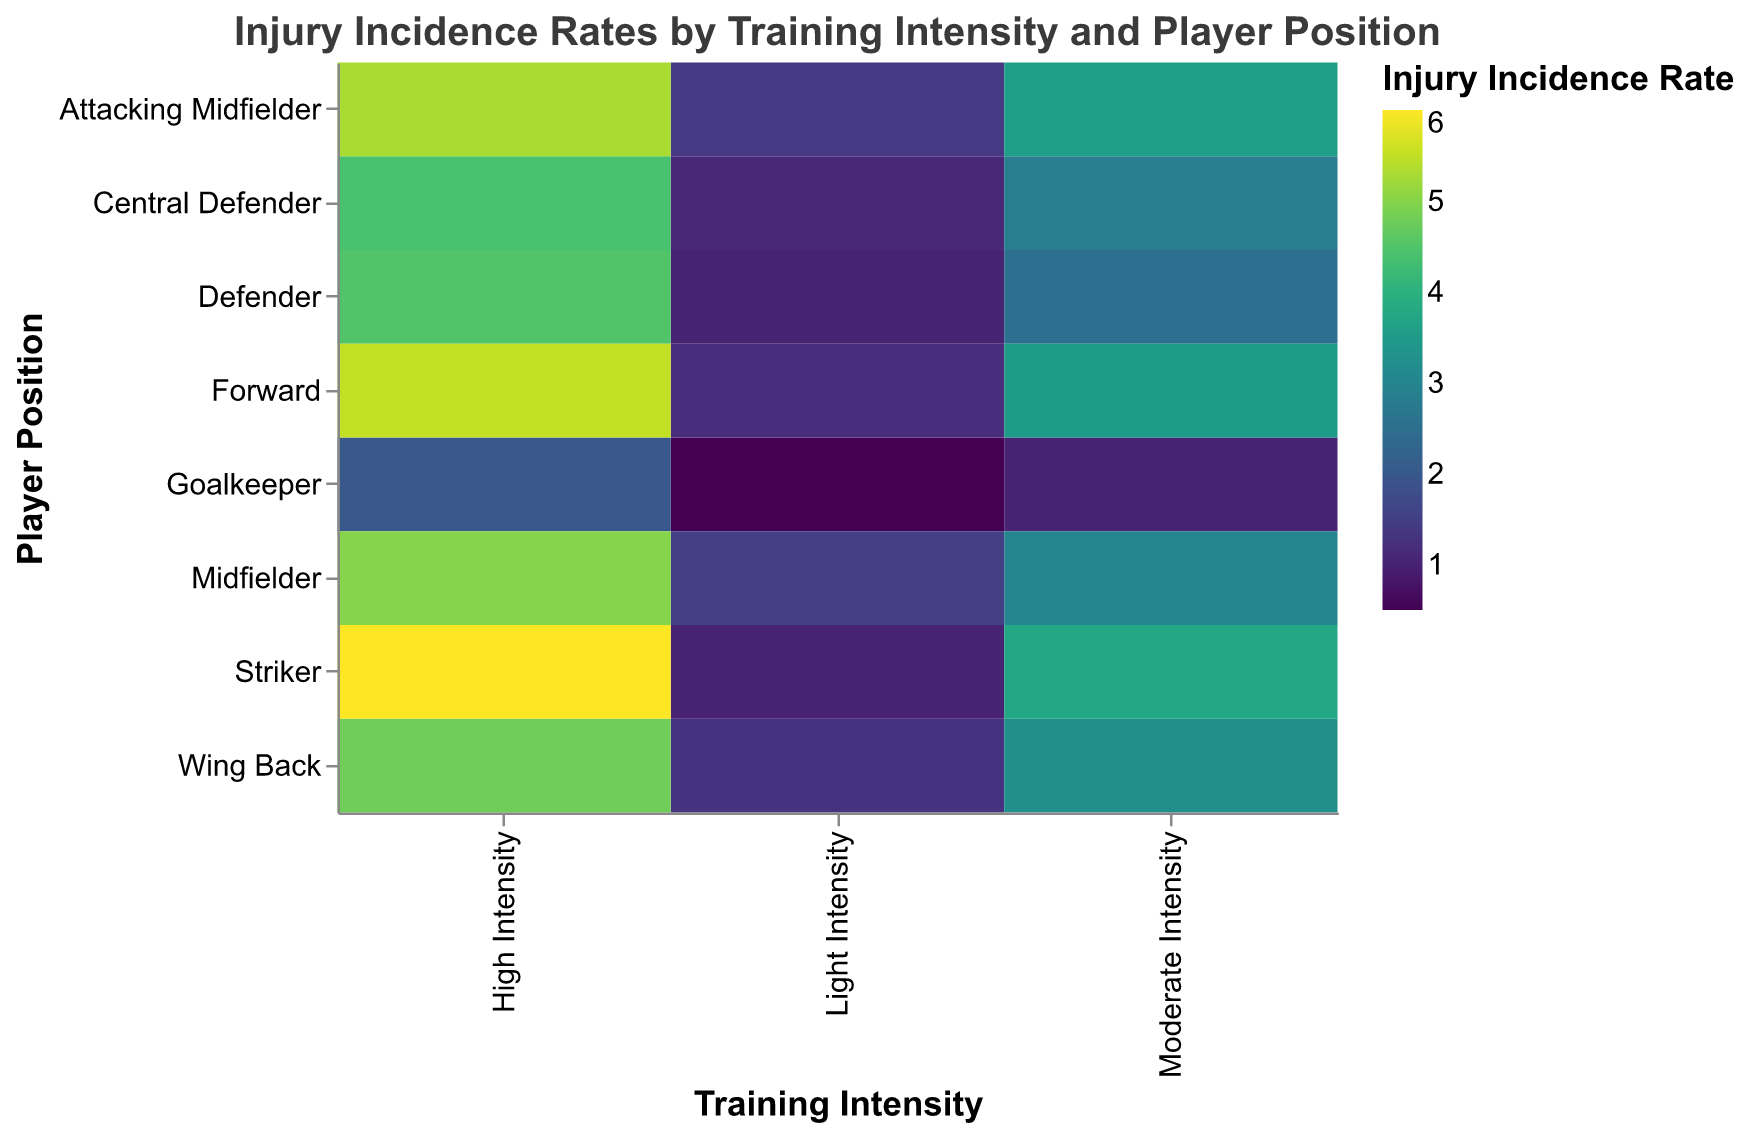What's the title of the heatmap? The title is placed at the top of the heatmap. It is clearly shown and readable.
Answer: Injury Incidence Rates by Training Intensity and Player Position How many different training intensities are displayed in the heatmap? The heatmap's X-axis represents the training intensities. There are three labels displayed, which indicate the number of unique training intensities.
Answer: Three Which player position has the highest injury incidence rate under High Intensity training? To find this, look at the column for High Intensity and identify the player position with the darkest color box or the highest value.
Answer: Striker What is the injury incidence rate for a Goalkeeper at Moderate Intensity? Locate the row for Goalkeeper and the column for Moderate Intensity. The corresponding value or color intensity in that cell represents the injury incidence rate.
Answer: 1.0 Compare the injury incidence rates of Defenders under Light Intensity and High Intensity. Find the values for Defenders in both the Light Intensity and High Intensity columns and compare them. Light Intensity has 1.0, and High Intensity has 4.5.
Answer: Higher at High Intensity (4.5 vs 1.0) Which player position experiences an injury incidence rate of 3.6 at Moderate Intensity? In the Moderate Intensity column, scan for the value 3.6 and check the corresponding player position row.
Answer: Attacking Midfielder Calculate the average injury incidence rate for Midfielders across all training intensities. Sum the values for Midfielders at Light Intensity (1.5), Moderate Intensity (3.0), and High Intensity (5.0) and divide by the number of intensities (3). (1.5 + 3.0 + 5.0) / 3 = 3.2.
Answer: 3.2 Which player position shows the least increase in injury incidence rate between Moderate and High Intensity? For each player position, subtract the Moderate Intensity rate from the High Intensity rate and find the smallest difference. Goalkeeper has (2.0 - 1.0 = 1.0) which is the smallest increase.
Answer: Goalkeeper What training intensity generally results in the highest injury incidence rates? By analyzing the darkest shades and highest values across the heatmap, you can observe that High Intensity generally has higher values.
Answer: High Intensity Identify the player position with the most consistent injury incidence rates across all intensities. The player position with the smallest range (difference between highest and lowest rate) across all intensities is Goalkeeper (difference = 2.0 - 0.5 = 1.5).
Answer: Goalkeeper 